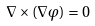<formula> <loc_0><loc_0><loc_500><loc_500>\nabla \times ( \nabla \varphi ) = 0</formula> 